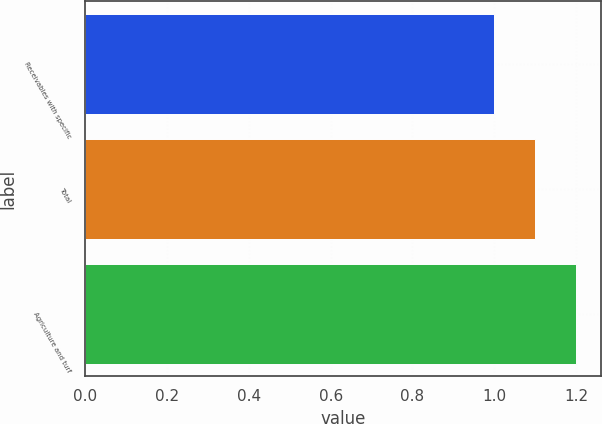<chart> <loc_0><loc_0><loc_500><loc_500><bar_chart><fcel>Receivables with specific<fcel>Total<fcel>Agriculture and turf<nl><fcel>1<fcel>1.1<fcel>1.2<nl></chart> 